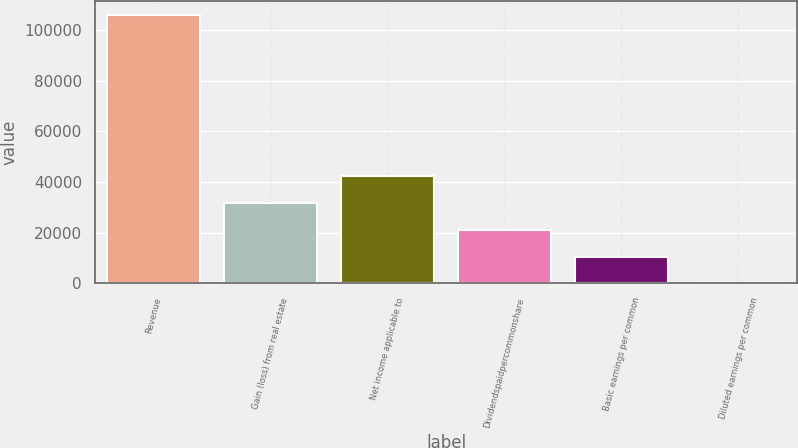Convert chart to OTSL. <chart><loc_0><loc_0><loc_500><loc_500><bar_chart><fcel>Revenue<fcel>Gain (loss) from real estate<fcel>Net income applicable to<fcel>Dividendspaidpercommonshare<fcel>Basic earnings per common<fcel>Diluted earnings per common<nl><fcel>106001<fcel>31800.5<fcel>42400.6<fcel>21200.4<fcel>10600.3<fcel>0.27<nl></chart> 